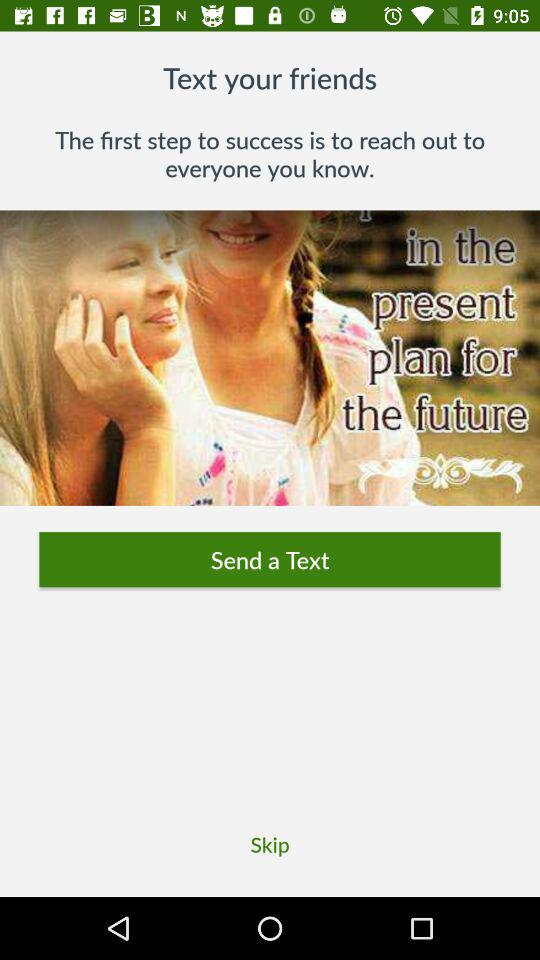What is the first step to success? The first step to success is to reach out to everyone you know. 